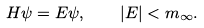Convert formula to latex. <formula><loc_0><loc_0><loc_500><loc_500>H \psi = E \psi , \quad | E | < m _ { \infty } .</formula> 